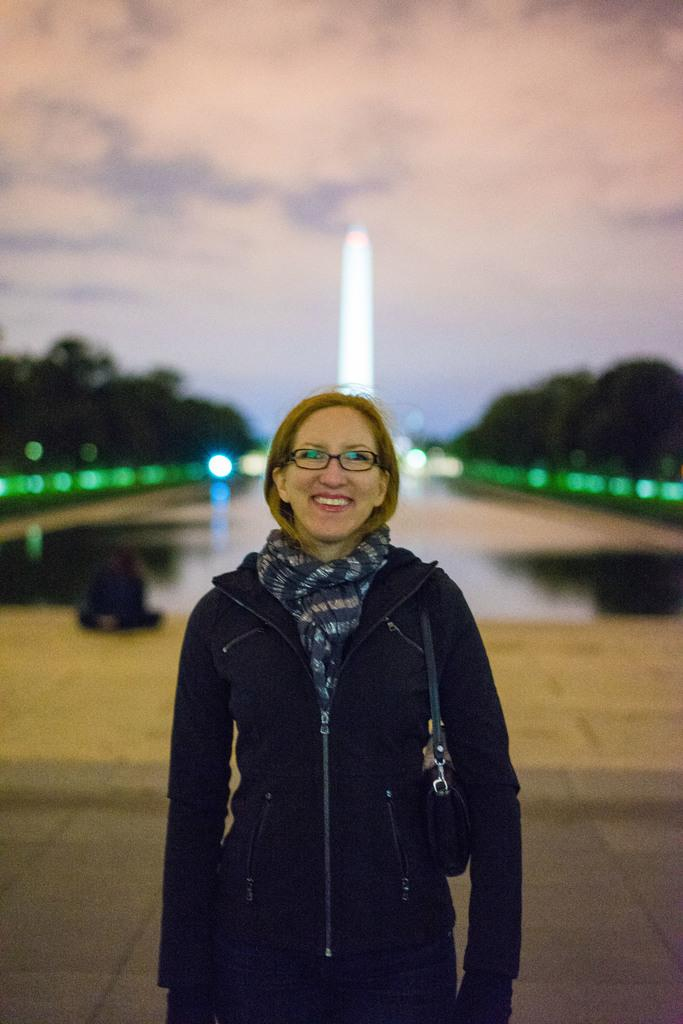Who is the main subject in the image? There is a woman in the center of the image. What is the woman wearing? The woman is wearing a black jacket and a scarf. What is the woman carrying in the image? The woman is carrying a bag. What can be seen in the background of the image? There are trees and the sky visible in the background of the image. What type of corn is being cooked in the image? There is no corn or cooking activity present in the image. How much sugar is being used by the woman in the image? There is no sugar or cooking activity present in the image. 